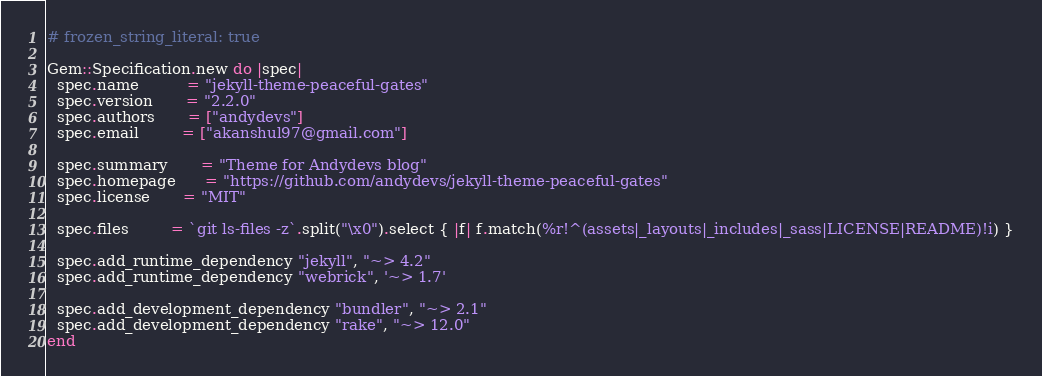<code> <loc_0><loc_0><loc_500><loc_500><_Ruby_># frozen_string_literal: true

Gem::Specification.new do |spec|
  spec.name          = "jekyll-theme-peaceful-gates"
  spec.version       = "2.2.0"
  spec.authors       = ["andydevs"]
  spec.email         = ["akanshul97@gmail.com"]

  spec.summary       = "Theme for Andydevs blog"
  spec.homepage      = "https://github.com/andydevs/jekyll-theme-peaceful-gates"
  spec.license       = "MIT"

  spec.files         = `git ls-files -z`.split("\x0").select { |f| f.match(%r!^(assets|_layouts|_includes|_sass|LICENSE|README)!i) }

  spec.add_runtime_dependency "jekyll", "~> 4.2"
  spec.add_runtime_dependency "webrick", '~> 1.7'

  spec.add_development_dependency "bundler", "~> 2.1"
  spec.add_development_dependency "rake", "~> 12.0"
end
</code> 